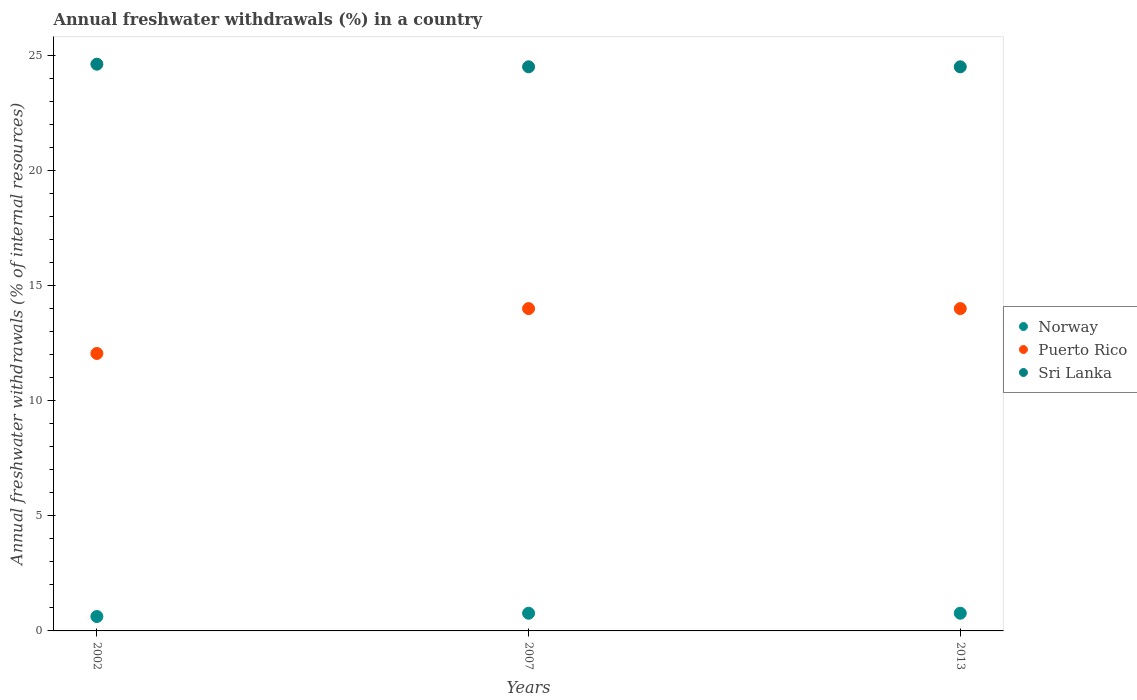How many different coloured dotlines are there?
Offer a terse response. 3. Is the number of dotlines equal to the number of legend labels?
Ensure brevity in your answer.  Yes. What is the percentage of annual freshwater withdrawals in Sri Lanka in 2002?
Make the answer very short. 24.64. Across all years, what is the maximum percentage of annual freshwater withdrawals in Norway?
Your answer should be very brief. 0.77. Across all years, what is the minimum percentage of annual freshwater withdrawals in Puerto Rico?
Your answer should be very brief. 12.06. In which year was the percentage of annual freshwater withdrawals in Sri Lanka minimum?
Give a very brief answer. 2007. What is the total percentage of annual freshwater withdrawals in Puerto Rico in the graph?
Offer a terse response. 40.09. What is the difference between the percentage of annual freshwater withdrawals in Puerto Rico in 2002 and the percentage of annual freshwater withdrawals in Norway in 2013?
Make the answer very short. 11.29. What is the average percentage of annual freshwater withdrawals in Puerto Rico per year?
Your response must be concise. 13.36. In the year 2007, what is the difference between the percentage of annual freshwater withdrawals in Sri Lanka and percentage of annual freshwater withdrawals in Puerto Rico?
Ensure brevity in your answer.  10.51. In how many years, is the percentage of annual freshwater withdrawals in Sri Lanka greater than 3 %?
Provide a short and direct response. 3. What is the ratio of the percentage of annual freshwater withdrawals in Norway in 2002 to that in 2013?
Offer a very short reply. 0.81. Is the difference between the percentage of annual freshwater withdrawals in Sri Lanka in 2002 and 2007 greater than the difference between the percentage of annual freshwater withdrawals in Puerto Rico in 2002 and 2007?
Offer a terse response. Yes. What is the difference between the highest and the second highest percentage of annual freshwater withdrawals in Sri Lanka?
Give a very brief answer. 0.11. What is the difference between the highest and the lowest percentage of annual freshwater withdrawals in Norway?
Give a very brief answer. 0.14. Is the sum of the percentage of annual freshwater withdrawals in Puerto Rico in 2002 and 2007 greater than the maximum percentage of annual freshwater withdrawals in Sri Lanka across all years?
Offer a terse response. Yes. Is the percentage of annual freshwater withdrawals in Norway strictly greater than the percentage of annual freshwater withdrawals in Sri Lanka over the years?
Your answer should be compact. No. How many dotlines are there?
Keep it short and to the point. 3. What is the difference between two consecutive major ticks on the Y-axis?
Provide a short and direct response. 5. Are the values on the major ticks of Y-axis written in scientific E-notation?
Your response must be concise. No. Where does the legend appear in the graph?
Ensure brevity in your answer.  Center right. What is the title of the graph?
Your response must be concise. Annual freshwater withdrawals (%) in a country. Does "Chile" appear as one of the legend labels in the graph?
Your response must be concise. No. What is the label or title of the Y-axis?
Make the answer very short. Annual freshwater withdrawals (% of internal resources). What is the Annual freshwater withdrawals (% of internal resources) in Norway in 2002?
Provide a short and direct response. 0.63. What is the Annual freshwater withdrawals (% of internal resources) in Puerto Rico in 2002?
Your response must be concise. 12.06. What is the Annual freshwater withdrawals (% of internal resources) of Sri Lanka in 2002?
Your response must be concise. 24.64. What is the Annual freshwater withdrawals (% of internal resources) in Norway in 2007?
Provide a short and direct response. 0.77. What is the Annual freshwater withdrawals (% of internal resources) of Puerto Rico in 2007?
Your answer should be very brief. 14.01. What is the Annual freshwater withdrawals (% of internal resources) of Sri Lanka in 2007?
Give a very brief answer. 24.53. What is the Annual freshwater withdrawals (% of internal resources) in Norway in 2013?
Your answer should be very brief. 0.77. What is the Annual freshwater withdrawals (% of internal resources) in Puerto Rico in 2013?
Offer a terse response. 14.01. What is the Annual freshwater withdrawals (% of internal resources) of Sri Lanka in 2013?
Keep it short and to the point. 24.53. Across all years, what is the maximum Annual freshwater withdrawals (% of internal resources) of Norway?
Offer a very short reply. 0.77. Across all years, what is the maximum Annual freshwater withdrawals (% of internal resources) in Puerto Rico?
Ensure brevity in your answer.  14.01. Across all years, what is the maximum Annual freshwater withdrawals (% of internal resources) of Sri Lanka?
Offer a very short reply. 24.64. Across all years, what is the minimum Annual freshwater withdrawals (% of internal resources) of Norway?
Ensure brevity in your answer.  0.63. Across all years, what is the minimum Annual freshwater withdrawals (% of internal resources) of Puerto Rico?
Your response must be concise. 12.06. Across all years, what is the minimum Annual freshwater withdrawals (% of internal resources) in Sri Lanka?
Ensure brevity in your answer.  24.53. What is the total Annual freshwater withdrawals (% of internal resources) of Norway in the graph?
Make the answer very short. 2.17. What is the total Annual freshwater withdrawals (% of internal resources) in Puerto Rico in the graph?
Offer a terse response. 40.09. What is the total Annual freshwater withdrawals (% of internal resources) in Sri Lanka in the graph?
Your answer should be very brief. 73.69. What is the difference between the Annual freshwater withdrawals (% of internal resources) of Norway in 2002 and that in 2007?
Provide a succinct answer. -0.14. What is the difference between the Annual freshwater withdrawals (% of internal resources) of Puerto Rico in 2002 and that in 2007?
Your answer should be very brief. -1.95. What is the difference between the Annual freshwater withdrawals (% of internal resources) in Sri Lanka in 2002 and that in 2007?
Keep it short and to the point. 0.11. What is the difference between the Annual freshwater withdrawals (% of internal resources) in Norway in 2002 and that in 2013?
Keep it short and to the point. -0.14. What is the difference between the Annual freshwater withdrawals (% of internal resources) of Puerto Rico in 2002 and that in 2013?
Ensure brevity in your answer.  -1.95. What is the difference between the Annual freshwater withdrawals (% of internal resources) in Sri Lanka in 2002 and that in 2013?
Provide a short and direct response. 0.11. What is the difference between the Annual freshwater withdrawals (% of internal resources) in Norway in 2007 and that in 2013?
Your answer should be very brief. 0. What is the difference between the Annual freshwater withdrawals (% of internal resources) in Puerto Rico in 2007 and that in 2013?
Offer a terse response. 0. What is the difference between the Annual freshwater withdrawals (% of internal resources) in Sri Lanka in 2007 and that in 2013?
Your response must be concise. 0. What is the difference between the Annual freshwater withdrawals (% of internal resources) of Norway in 2002 and the Annual freshwater withdrawals (% of internal resources) of Puerto Rico in 2007?
Provide a succinct answer. -13.39. What is the difference between the Annual freshwater withdrawals (% of internal resources) in Norway in 2002 and the Annual freshwater withdrawals (% of internal resources) in Sri Lanka in 2007?
Provide a succinct answer. -23.9. What is the difference between the Annual freshwater withdrawals (% of internal resources) in Puerto Rico in 2002 and the Annual freshwater withdrawals (% of internal resources) in Sri Lanka in 2007?
Make the answer very short. -12.46. What is the difference between the Annual freshwater withdrawals (% of internal resources) in Norway in 2002 and the Annual freshwater withdrawals (% of internal resources) in Puerto Rico in 2013?
Your answer should be compact. -13.39. What is the difference between the Annual freshwater withdrawals (% of internal resources) in Norway in 2002 and the Annual freshwater withdrawals (% of internal resources) in Sri Lanka in 2013?
Offer a terse response. -23.9. What is the difference between the Annual freshwater withdrawals (% of internal resources) in Puerto Rico in 2002 and the Annual freshwater withdrawals (% of internal resources) in Sri Lanka in 2013?
Give a very brief answer. -12.46. What is the difference between the Annual freshwater withdrawals (% of internal resources) of Norway in 2007 and the Annual freshwater withdrawals (% of internal resources) of Puerto Rico in 2013?
Your response must be concise. -13.24. What is the difference between the Annual freshwater withdrawals (% of internal resources) in Norway in 2007 and the Annual freshwater withdrawals (% of internal resources) in Sri Lanka in 2013?
Offer a very short reply. -23.76. What is the difference between the Annual freshwater withdrawals (% of internal resources) in Puerto Rico in 2007 and the Annual freshwater withdrawals (% of internal resources) in Sri Lanka in 2013?
Your response must be concise. -10.51. What is the average Annual freshwater withdrawals (% of internal resources) of Norway per year?
Your answer should be very brief. 0.72. What is the average Annual freshwater withdrawals (% of internal resources) of Puerto Rico per year?
Your answer should be very brief. 13.36. What is the average Annual freshwater withdrawals (% of internal resources) in Sri Lanka per year?
Offer a terse response. 24.56. In the year 2002, what is the difference between the Annual freshwater withdrawals (% of internal resources) in Norway and Annual freshwater withdrawals (% of internal resources) in Puerto Rico?
Offer a very short reply. -11.44. In the year 2002, what is the difference between the Annual freshwater withdrawals (% of internal resources) of Norway and Annual freshwater withdrawals (% of internal resources) of Sri Lanka?
Offer a terse response. -24.01. In the year 2002, what is the difference between the Annual freshwater withdrawals (% of internal resources) in Puerto Rico and Annual freshwater withdrawals (% of internal resources) in Sri Lanka?
Keep it short and to the point. -12.58. In the year 2007, what is the difference between the Annual freshwater withdrawals (% of internal resources) in Norway and Annual freshwater withdrawals (% of internal resources) in Puerto Rico?
Ensure brevity in your answer.  -13.24. In the year 2007, what is the difference between the Annual freshwater withdrawals (% of internal resources) in Norway and Annual freshwater withdrawals (% of internal resources) in Sri Lanka?
Your answer should be compact. -23.76. In the year 2007, what is the difference between the Annual freshwater withdrawals (% of internal resources) in Puerto Rico and Annual freshwater withdrawals (% of internal resources) in Sri Lanka?
Ensure brevity in your answer.  -10.51. In the year 2013, what is the difference between the Annual freshwater withdrawals (% of internal resources) in Norway and Annual freshwater withdrawals (% of internal resources) in Puerto Rico?
Ensure brevity in your answer.  -13.24. In the year 2013, what is the difference between the Annual freshwater withdrawals (% of internal resources) in Norway and Annual freshwater withdrawals (% of internal resources) in Sri Lanka?
Your answer should be very brief. -23.76. In the year 2013, what is the difference between the Annual freshwater withdrawals (% of internal resources) in Puerto Rico and Annual freshwater withdrawals (% of internal resources) in Sri Lanka?
Provide a short and direct response. -10.51. What is the ratio of the Annual freshwater withdrawals (% of internal resources) of Norway in 2002 to that in 2007?
Make the answer very short. 0.81. What is the ratio of the Annual freshwater withdrawals (% of internal resources) in Puerto Rico in 2002 to that in 2007?
Provide a short and direct response. 0.86. What is the ratio of the Annual freshwater withdrawals (% of internal resources) of Sri Lanka in 2002 to that in 2007?
Your answer should be very brief. 1. What is the ratio of the Annual freshwater withdrawals (% of internal resources) of Norway in 2002 to that in 2013?
Provide a short and direct response. 0.81. What is the ratio of the Annual freshwater withdrawals (% of internal resources) in Puerto Rico in 2002 to that in 2013?
Provide a succinct answer. 0.86. What is the ratio of the Annual freshwater withdrawals (% of internal resources) in Sri Lanka in 2002 to that in 2013?
Ensure brevity in your answer.  1. What is the ratio of the Annual freshwater withdrawals (% of internal resources) in Sri Lanka in 2007 to that in 2013?
Give a very brief answer. 1. What is the difference between the highest and the second highest Annual freshwater withdrawals (% of internal resources) in Puerto Rico?
Offer a terse response. 0. What is the difference between the highest and the second highest Annual freshwater withdrawals (% of internal resources) of Sri Lanka?
Your answer should be compact. 0.11. What is the difference between the highest and the lowest Annual freshwater withdrawals (% of internal resources) of Norway?
Give a very brief answer. 0.14. What is the difference between the highest and the lowest Annual freshwater withdrawals (% of internal resources) in Puerto Rico?
Your response must be concise. 1.95. What is the difference between the highest and the lowest Annual freshwater withdrawals (% of internal resources) in Sri Lanka?
Offer a terse response. 0.11. 